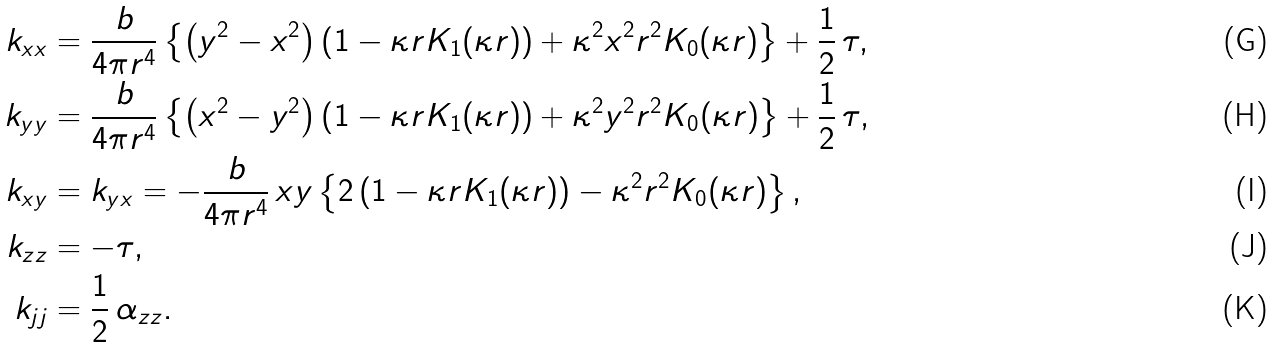<formula> <loc_0><loc_0><loc_500><loc_500>k _ { x x } & = \frac { b } { 4 \pi r ^ { 4 } } \left \{ \left ( y ^ { 2 } - x ^ { 2 } \right ) \left ( 1 - \kappa r K _ { 1 } ( \kappa r ) \right ) + \kappa ^ { 2 } x ^ { 2 } r ^ { 2 } K _ { 0 } ( \kappa r ) \right \} + \frac { 1 } { 2 } \, \tau , \\ k _ { y y } & = \frac { b } { 4 \pi r ^ { 4 } } \left \{ \left ( x ^ { 2 } - y ^ { 2 } \right ) \left ( 1 - \kappa r K _ { 1 } ( \kappa r ) \right ) + \kappa ^ { 2 } y ^ { 2 } r ^ { 2 } K _ { 0 } ( \kappa r ) \right \} + \frac { 1 } { 2 } \, \tau , \\ k _ { x y } & = k _ { y x } = - \frac { b } { 4 \pi r ^ { 4 } } \, x y \left \{ 2 \left ( 1 - \kappa r K _ { 1 } ( \kappa r ) \right ) - \kappa ^ { 2 } r ^ { 2 } K _ { 0 } ( \kappa r ) \right \} , \\ k _ { z z } & = - \tau , \\ k _ { j j } & = \frac { 1 } { 2 } \, \alpha _ { z z } .</formula> 